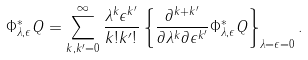<formula> <loc_0><loc_0><loc_500><loc_500>\Phi ^ { * } _ { \lambda , \epsilon } Q = \sum ^ { \infty } _ { k , k ^ { \prime } = 0 } \frac { \lambda ^ { k } \epsilon ^ { k ^ { \prime } } } { k ! k ^ { \prime } ! } \left \{ \frac { \partial ^ { k + k ^ { \prime } } } { \partial \lambda ^ { k } \partial \epsilon ^ { k ^ { \prime } } } \Phi ^ { * } _ { \lambda , \epsilon } Q \right \} _ { \lambda = \epsilon = 0 } .</formula> 